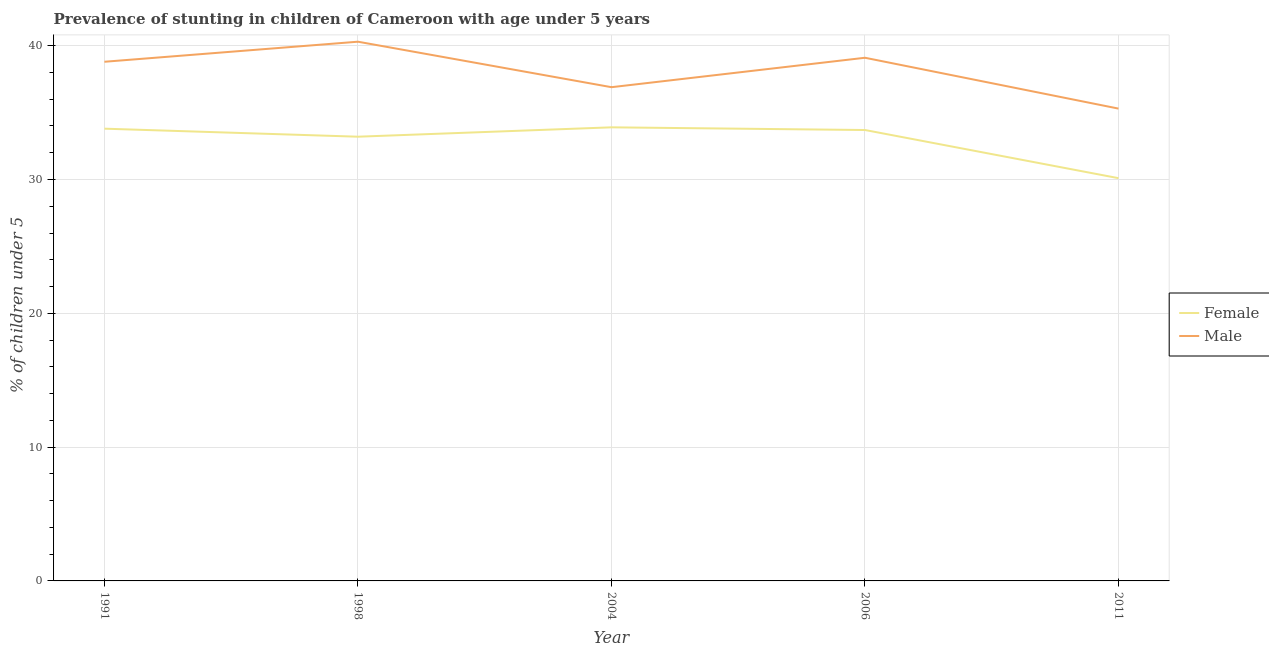How many different coloured lines are there?
Your response must be concise. 2. What is the percentage of stunted female children in 2006?
Offer a terse response. 33.7. Across all years, what is the maximum percentage of stunted female children?
Offer a terse response. 33.9. Across all years, what is the minimum percentage of stunted female children?
Give a very brief answer. 30.1. In which year was the percentage of stunted male children maximum?
Make the answer very short. 1998. In which year was the percentage of stunted female children minimum?
Provide a succinct answer. 2011. What is the total percentage of stunted male children in the graph?
Offer a very short reply. 190.4. What is the difference between the percentage of stunted female children in 2004 and that in 2011?
Your answer should be very brief. 3.8. What is the difference between the percentage of stunted male children in 2006 and the percentage of stunted female children in 1998?
Give a very brief answer. 5.9. What is the average percentage of stunted male children per year?
Provide a short and direct response. 38.08. In the year 2011, what is the difference between the percentage of stunted female children and percentage of stunted male children?
Make the answer very short. -5.2. In how many years, is the percentage of stunted female children greater than 6 %?
Ensure brevity in your answer.  5. What is the ratio of the percentage of stunted male children in 1998 to that in 2011?
Offer a terse response. 1.14. Is the percentage of stunted male children in 1991 less than that in 2006?
Keep it short and to the point. Yes. What is the difference between the highest and the second highest percentage of stunted male children?
Keep it short and to the point. 1.2. What is the difference between the highest and the lowest percentage of stunted female children?
Make the answer very short. 3.8. How many years are there in the graph?
Your answer should be compact. 5. What is the difference between two consecutive major ticks on the Y-axis?
Your answer should be compact. 10. Does the graph contain any zero values?
Keep it short and to the point. No. Does the graph contain grids?
Provide a succinct answer. Yes. Where does the legend appear in the graph?
Give a very brief answer. Center right. How are the legend labels stacked?
Keep it short and to the point. Vertical. What is the title of the graph?
Your answer should be compact. Prevalence of stunting in children of Cameroon with age under 5 years. Does "Number of departures" appear as one of the legend labels in the graph?
Your answer should be compact. No. What is the label or title of the Y-axis?
Your answer should be very brief.  % of children under 5. What is the  % of children under 5 of Female in 1991?
Make the answer very short. 33.8. What is the  % of children under 5 in Male in 1991?
Ensure brevity in your answer.  38.8. What is the  % of children under 5 of Female in 1998?
Ensure brevity in your answer.  33.2. What is the  % of children under 5 of Male in 1998?
Keep it short and to the point. 40.3. What is the  % of children under 5 in Female in 2004?
Keep it short and to the point. 33.9. What is the  % of children under 5 of Male in 2004?
Your response must be concise. 36.9. What is the  % of children under 5 in Female in 2006?
Your answer should be very brief. 33.7. What is the  % of children under 5 in Male in 2006?
Your answer should be compact. 39.1. What is the  % of children under 5 in Female in 2011?
Make the answer very short. 30.1. What is the  % of children under 5 of Male in 2011?
Give a very brief answer. 35.3. Across all years, what is the maximum  % of children under 5 in Female?
Offer a very short reply. 33.9. Across all years, what is the maximum  % of children under 5 in Male?
Your answer should be very brief. 40.3. Across all years, what is the minimum  % of children under 5 of Female?
Your answer should be compact. 30.1. Across all years, what is the minimum  % of children under 5 of Male?
Offer a very short reply. 35.3. What is the total  % of children under 5 in Female in the graph?
Provide a succinct answer. 164.7. What is the total  % of children under 5 of Male in the graph?
Your answer should be very brief. 190.4. What is the difference between the  % of children under 5 of Male in 1991 and that in 2011?
Ensure brevity in your answer.  3.5. What is the difference between the  % of children under 5 in Female in 1998 and that in 2004?
Your answer should be compact. -0.7. What is the difference between the  % of children under 5 in Female in 1998 and that in 2006?
Give a very brief answer. -0.5. What is the difference between the  % of children under 5 of Male in 1998 and that in 2006?
Your response must be concise. 1.2. What is the difference between the  % of children under 5 in Female in 1998 and that in 2011?
Keep it short and to the point. 3.1. What is the difference between the  % of children under 5 in Male in 1998 and that in 2011?
Ensure brevity in your answer.  5. What is the difference between the  % of children under 5 of Female in 2004 and that in 2006?
Offer a very short reply. 0.2. What is the difference between the  % of children under 5 of Female in 2004 and that in 2011?
Provide a short and direct response. 3.8. What is the difference between the  % of children under 5 of Female in 1991 and the  % of children under 5 of Male in 1998?
Keep it short and to the point. -6.5. What is the difference between the  % of children under 5 of Female in 1991 and the  % of children under 5 of Male in 2004?
Provide a short and direct response. -3.1. What is the difference between the  % of children under 5 in Female in 1998 and the  % of children under 5 in Male in 2004?
Your answer should be very brief. -3.7. What is the difference between the  % of children under 5 of Female in 1998 and the  % of children under 5 of Male in 2011?
Your answer should be compact. -2.1. What is the difference between the  % of children under 5 in Female in 2004 and the  % of children under 5 in Male in 2011?
Provide a succinct answer. -1.4. What is the difference between the  % of children under 5 of Female in 2006 and the  % of children under 5 of Male in 2011?
Keep it short and to the point. -1.6. What is the average  % of children under 5 in Female per year?
Provide a short and direct response. 32.94. What is the average  % of children under 5 in Male per year?
Give a very brief answer. 38.08. In the year 1991, what is the difference between the  % of children under 5 of Female and  % of children under 5 of Male?
Provide a short and direct response. -5. In the year 1998, what is the difference between the  % of children under 5 in Female and  % of children under 5 in Male?
Give a very brief answer. -7.1. In the year 2004, what is the difference between the  % of children under 5 in Female and  % of children under 5 in Male?
Give a very brief answer. -3. In the year 2006, what is the difference between the  % of children under 5 in Female and  % of children under 5 in Male?
Ensure brevity in your answer.  -5.4. In the year 2011, what is the difference between the  % of children under 5 in Female and  % of children under 5 in Male?
Provide a short and direct response. -5.2. What is the ratio of the  % of children under 5 in Female in 1991 to that in 1998?
Ensure brevity in your answer.  1.02. What is the ratio of the  % of children under 5 in Male in 1991 to that in 1998?
Make the answer very short. 0.96. What is the ratio of the  % of children under 5 of Female in 1991 to that in 2004?
Offer a terse response. 1. What is the ratio of the  % of children under 5 of Male in 1991 to that in 2004?
Give a very brief answer. 1.05. What is the ratio of the  % of children under 5 of Female in 1991 to that in 2006?
Ensure brevity in your answer.  1. What is the ratio of the  % of children under 5 in Male in 1991 to that in 2006?
Your response must be concise. 0.99. What is the ratio of the  % of children under 5 of Female in 1991 to that in 2011?
Your answer should be very brief. 1.12. What is the ratio of the  % of children under 5 of Male in 1991 to that in 2011?
Your response must be concise. 1.1. What is the ratio of the  % of children under 5 of Female in 1998 to that in 2004?
Keep it short and to the point. 0.98. What is the ratio of the  % of children under 5 in Male in 1998 to that in 2004?
Provide a short and direct response. 1.09. What is the ratio of the  % of children under 5 in Female in 1998 to that in 2006?
Provide a short and direct response. 0.99. What is the ratio of the  % of children under 5 in Male in 1998 to that in 2006?
Your answer should be very brief. 1.03. What is the ratio of the  % of children under 5 in Female in 1998 to that in 2011?
Keep it short and to the point. 1.1. What is the ratio of the  % of children under 5 of Male in 1998 to that in 2011?
Ensure brevity in your answer.  1.14. What is the ratio of the  % of children under 5 of Female in 2004 to that in 2006?
Your answer should be very brief. 1.01. What is the ratio of the  % of children under 5 of Male in 2004 to that in 2006?
Keep it short and to the point. 0.94. What is the ratio of the  % of children under 5 of Female in 2004 to that in 2011?
Provide a short and direct response. 1.13. What is the ratio of the  % of children under 5 of Male in 2004 to that in 2011?
Keep it short and to the point. 1.05. What is the ratio of the  % of children under 5 of Female in 2006 to that in 2011?
Your answer should be compact. 1.12. What is the ratio of the  % of children under 5 of Male in 2006 to that in 2011?
Your answer should be very brief. 1.11. What is the difference between the highest and the second highest  % of children under 5 of Female?
Give a very brief answer. 0.1. What is the difference between the highest and the lowest  % of children under 5 in Female?
Ensure brevity in your answer.  3.8. 